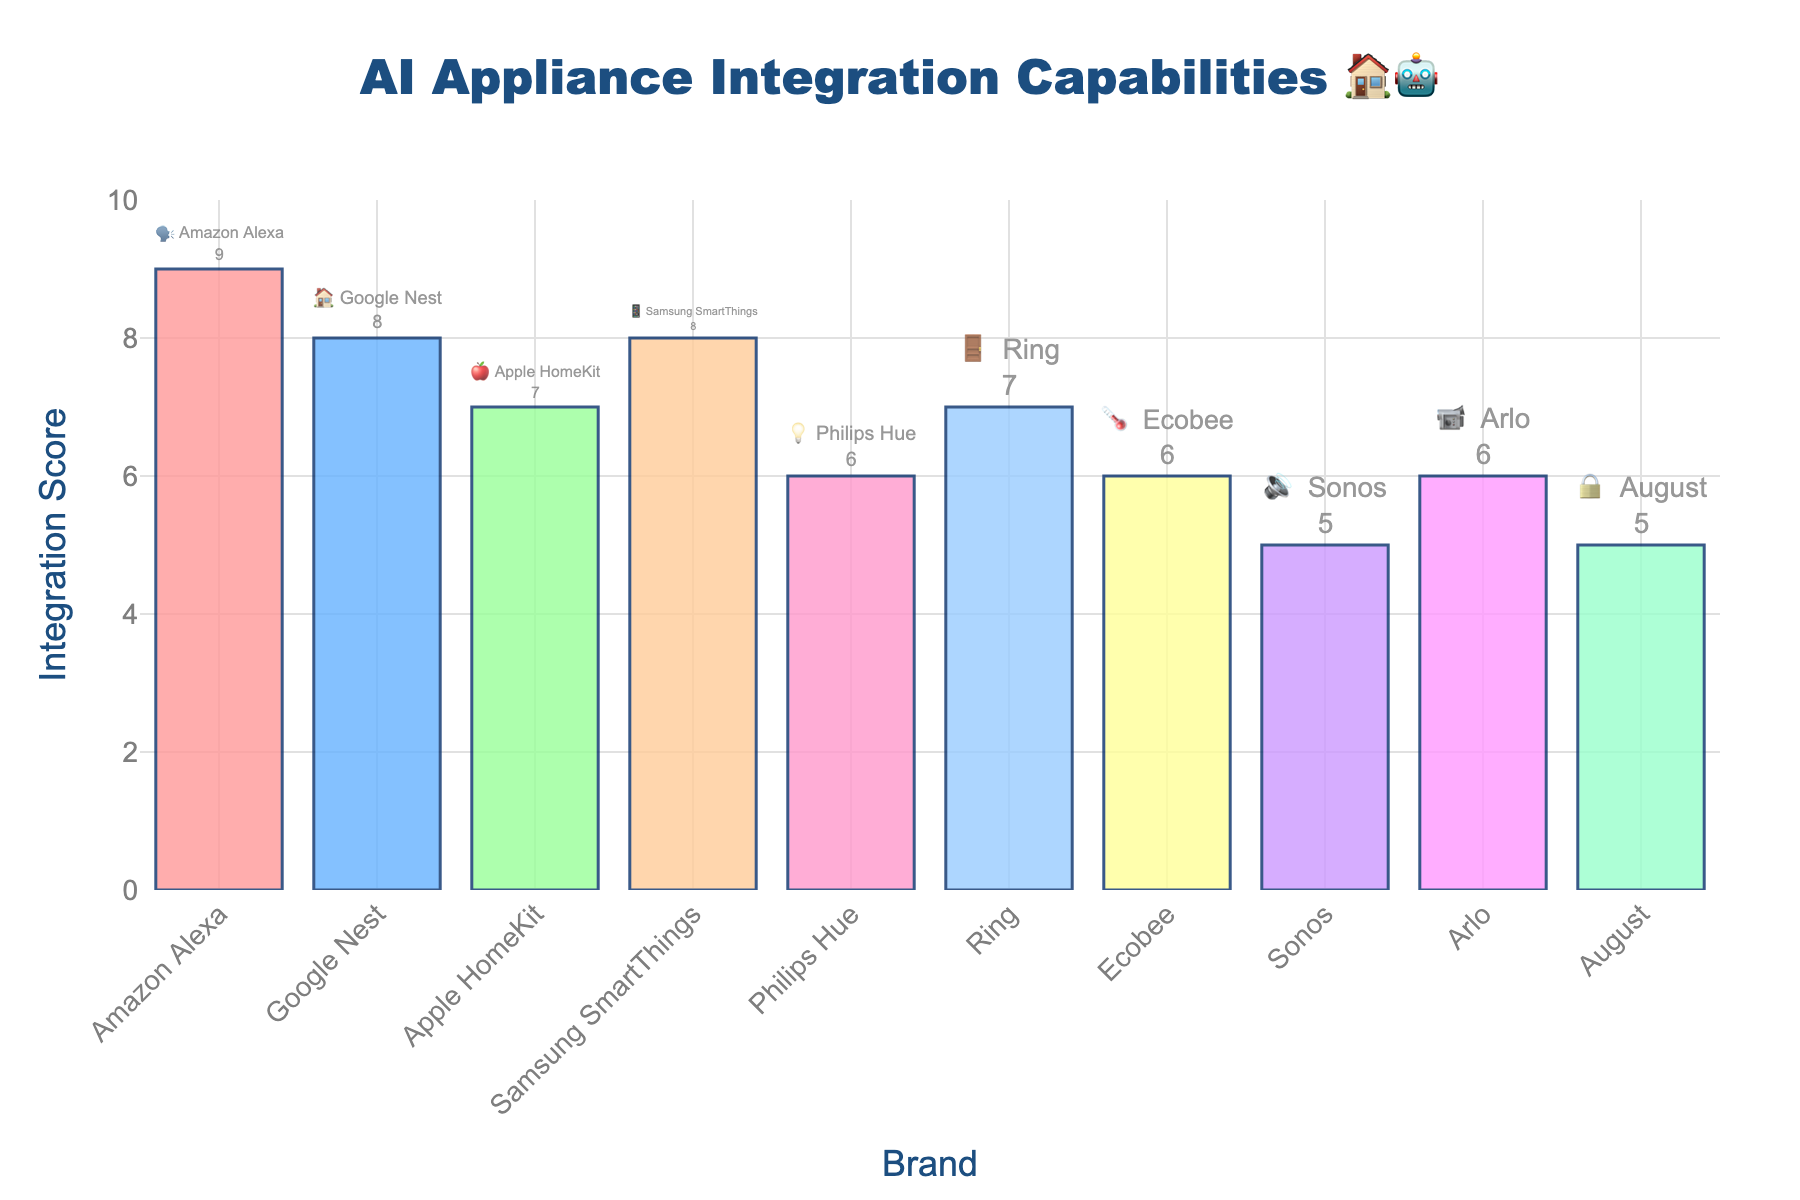What's the highest integration score and which brand has it? The chart shows various brands with their integration scores. Looking at the tallest bar, we can see that Amazon Alexa has the highest integration score.
Answer: 9, Amazon Alexa What's the average integration score of the brands listed? To find the average, sum all the integration scores and divide by the number of brands. The scores are 9, 8, 7, 8, 6, 7, 6, 5, 6, 5. The sum is 67, and there are 10 brands, so the average is 67/10.
Answer: 6.7 Which brands have an integration score of 6? From the chart, we can see that the brands with bars reaching to 6 are Philips Hue, Ecobee, and Arlo.
Answer: Philips Hue, Ecobee, Arlo How does the integration score of Google Nest compare with that of Ring? Google Nest has an integration score of 8, and Ring has a score of 7. Google Nest's score is higher than Ring's score.
Answer: Google Nest has a higher score Which brand has the lowest integration score and what is it? The lowest score in the chart appears to be 5. Brands with this score are Sonos and August.
Answer: Sonos, August (score: 5) What is the difference in integration scores between Samsung SmartThings and Apple HomeKit? Samsung SmartThings has a score of 8, and Apple HomeKit has a score of 7. Subtract Apple HomeKit's score from Samsung SmartThings's score (8 - 7).
Answer: 1 What is the second highest integration score and which brands have it? The highest score is 9 (Amazon Alexa), so the second highest score is 8. Google Nest and Samsung SmartThings both have a score of 8.
Answer: 8, Google Nest, Samsung SmartThings How many brands have an integration score greater than 6? The brands with integration scores greater than 6 are Amazon Alexa (9), Google Nest (8), Samsung SmartThings (8), Apple HomeKit (7), and Ring (7). There are 5 such brands.
Answer: 5 Which emoji represents Apple HomeKit? The chart shows brands with their respective emojis. Apple HomeKit is represented by the 🍎 emoji.
Answer: 🍎 